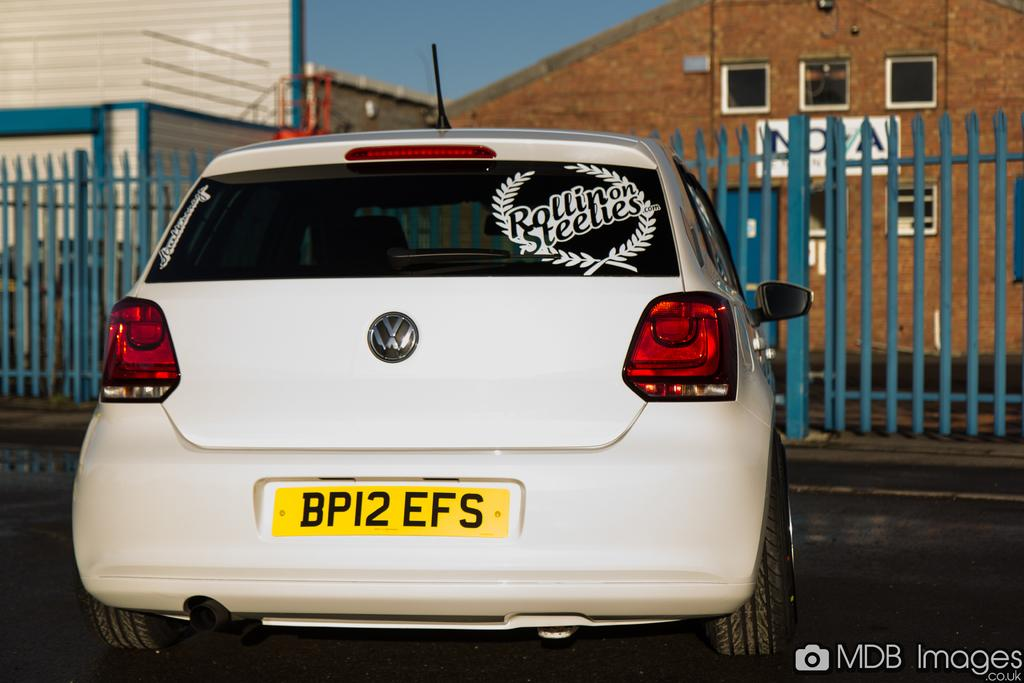<image>
Share a concise interpretation of the image provided. White volkswagon is parked with a rollin on steelies sign on the back 